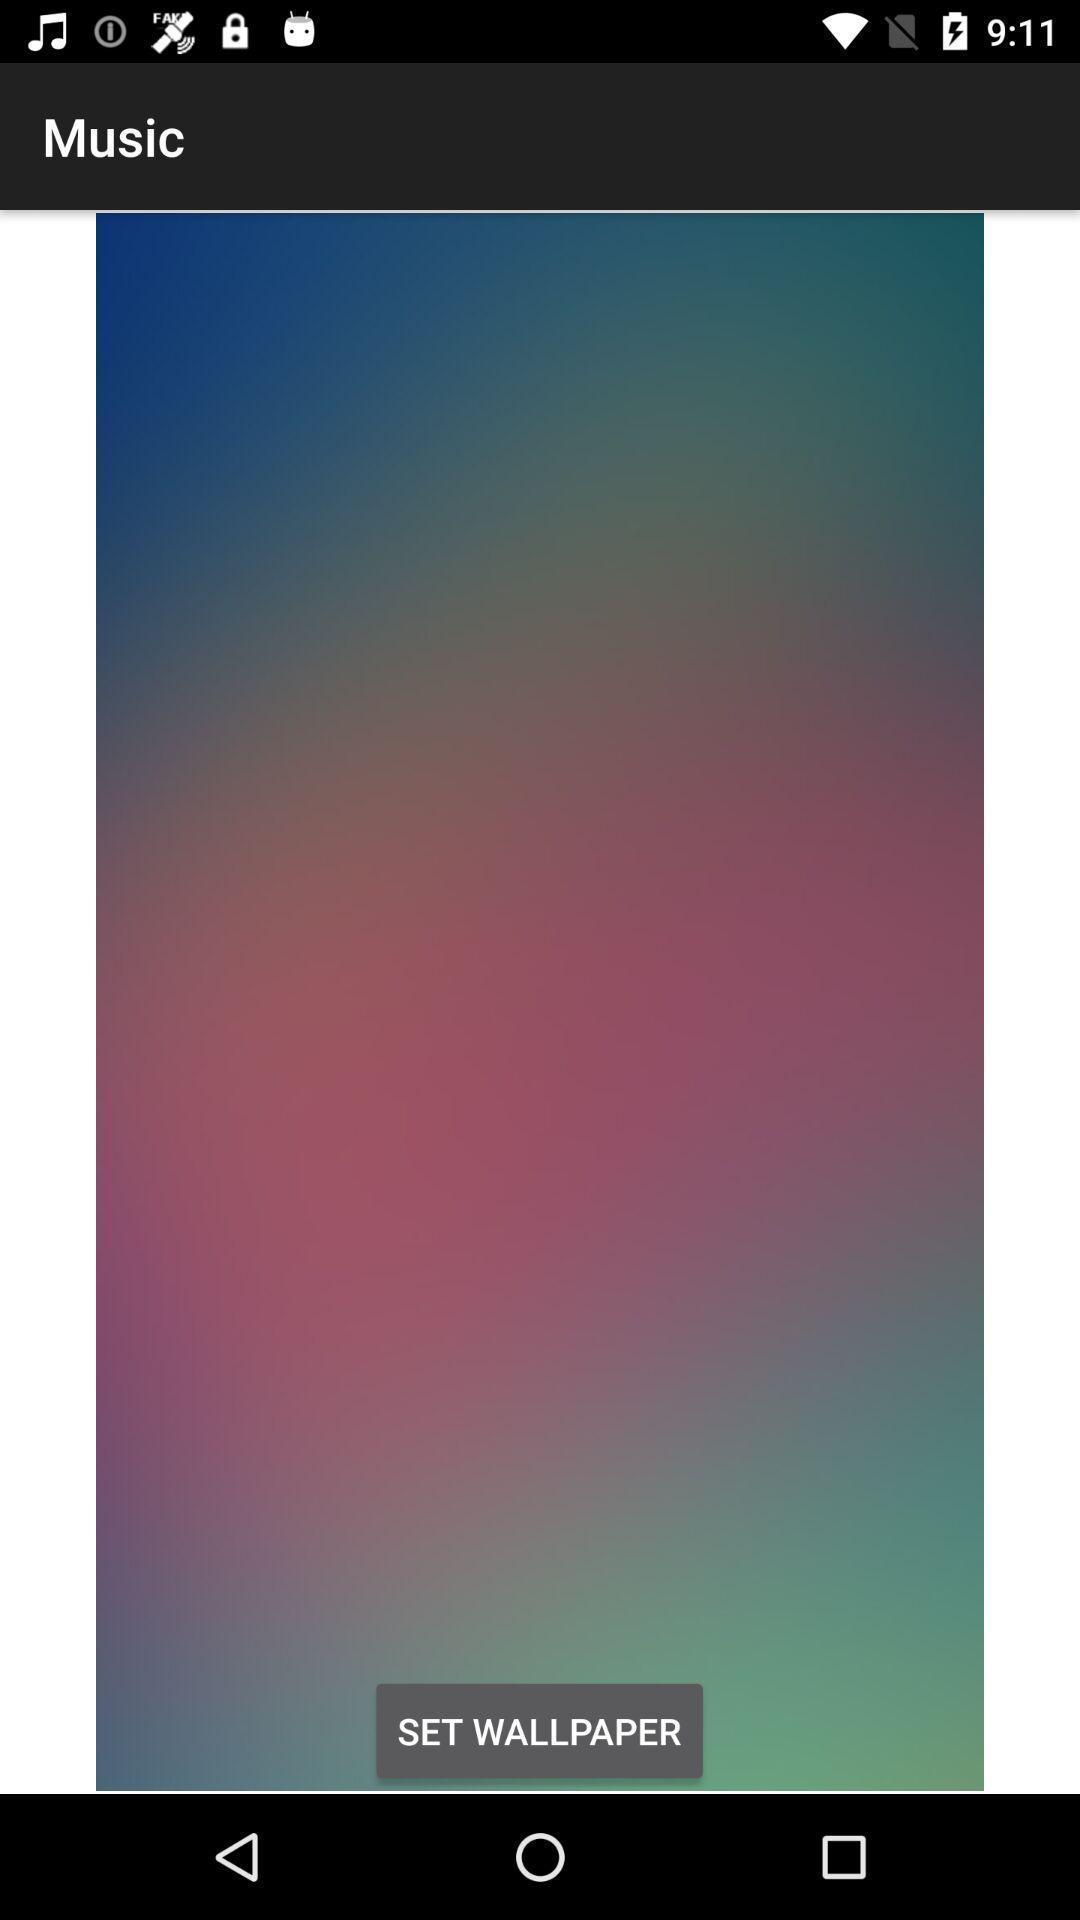Explain what's happening in this screen capture. Page displays to set wallpaper in app. 